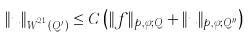<formula> <loc_0><loc_0><loc_500><loc_500>\| u \| _ { W ^ { 2 , 1 } _ { p , \varphi } ( Q ^ { \prime } ) } \leq C \left ( \| f \| _ { p , \varphi ; Q } + \| u \| _ { p , \varphi ; Q ^ { \prime \prime } } \right )</formula> 